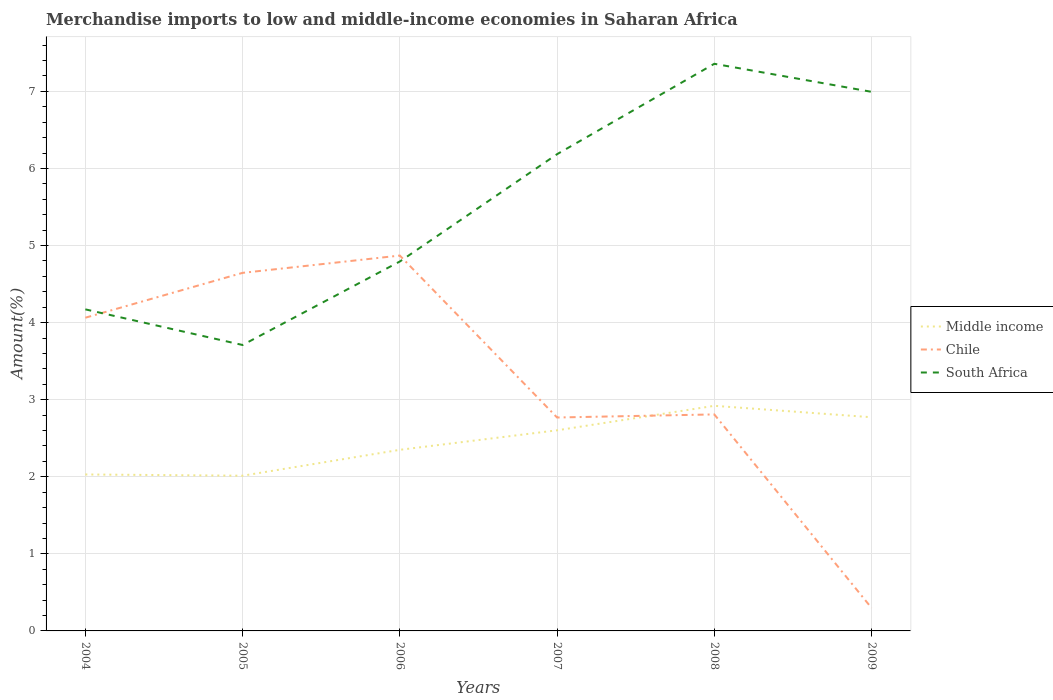Does the line corresponding to Chile intersect with the line corresponding to South Africa?
Offer a very short reply. Yes. Across all years, what is the maximum percentage of amount earned from merchandise imports in Middle income?
Offer a very short reply. 2.01. In which year was the percentage of amount earned from merchandise imports in Middle income maximum?
Give a very brief answer. 2005. What is the total percentage of amount earned from merchandise imports in South Africa in the graph?
Provide a succinct answer. -1.08. What is the difference between the highest and the second highest percentage of amount earned from merchandise imports in Middle income?
Your answer should be very brief. 0.91. What is the difference between the highest and the lowest percentage of amount earned from merchandise imports in Middle income?
Provide a succinct answer. 3. Is the percentage of amount earned from merchandise imports in Middle income strictly greater than the percentage of amount earned from merchandise imports in South Africa over the years?
Ensure brevity in your answer.  Yes. Does the graph contain any zero values?
Your answer should be very brief. No. How many legend labels are there?
Provide a short and direct response. 3. How are the legend labels stacked?
Offer a very short reply. Vertical. What is the title of the graph?
Make the answer very short. Merchandise imports to low and middle-income economies in Saharan Africa. What is the label or title of the Y-axis?
Provide a short and direct response. Amount(%). What is the Amount(%) in Middle income in 2004?
Keep it short and to the point. 2.03. What is the Amount(%) in Chile in 2004?
Offer a terse response. 4.06. What is the Amount(%) in South Africa in 2004?
Offer a very short reply. 4.17. What is the Amount(%) in Middle income in 2005?
Give a very brief answer. 2.01. What is the Amount(%) of Chile in 2005?
Your answer should be very brief. 4.65. What is the Amount(%) of South Africa in 2005?
Keep it short and to the point. 3.71. What is the Amount(%) of Middle income in 2006?
Keep it short and to the point. 2.35. What is the Amount(%) in Chile in 2006?
Keep it short and to the point. 4.87. What is the Amount(%) in South Africa in 2006?
Keep it short and to the point. 4.79. What is the Amount(%) in Middle income in 2007?
Make the answer very short. 2.6. What is the Amount(%) in Chile in 2007?
Your answer should be very brief. 2.77. What is the Amount(%) in South Africa in 2007?
Give a very brief answer. 6.19. What is the Amount(%) in Middle income in 2008?
Make the answer very short. 2.92. What is the Amount(%) of Chile in 2008?
Your answer should be very brief. 2.81. What is the Amount(%) of South Africa in 2008?
Your answer should be compact. 7.36. What is the Amount(%) of Middle income in 2009?
Provide a succinct answer. 2.77. What is the Amount(%) in Chile in 2009?
Your answer should be very brief. 0.3. What is the Amount(%) in South Africa in 2009?
Give a very brief answer. 6.99. Across all years, what is the maximum Amount(%) of Middle income?
Your response must be concise. 2.92. Across all years, what is the maximum Amount(%) of Chile?
Your response must be concise. 4.87. Across all years, what is the maximum Amount(%) of South Africa?
Your response must be concise. 7.36. Across all years, what is the minimum Amount(%) of Middle income?
Offer a terse response. 2.01. Across all years, what is the minimum Amount(%) of Chile?
Offer a terse response. 0.3. Across all years, what is the minimum Amount(%) of South Africa?
Offer a very short reply. 3.71. What is the total Amount(%) in Middle income in the graph?
Offer a terse response. 14.69. What is the total Amount(%) of Chile in the graph?
Ensure brevity in your answer.  19.46. What is the total Amount(%) in South Africa in the graph?
Your response must be concise. 33.21. What is the difference between the Amount(%) of Middle income in 2004 and that in 2005?
Offer a terse response. 0.02. What is the difference between the Amount(%) in Chile in 2004 and that in 2005?
Your answer should be very brief. -0.58. What is the difference between the Amount(%) of South Africa in 2004 and that in 2005?
Ensure brevity in your answer.  0.46. What is the difference between the Amount(%) of Middle income in 2004 and that in 2006?
Provide a short and direct response. -0.32. What is the difference between the Amount(%) of Chile in 2004 and that in 2006?
Make the answer very short. -0.81. What is the difference between the Amount(%) in South Africa in 2004 and that in 2006?
Offer a very short reply. -0.62. What is the difference between the Amount(%) in Middle income in 2004 and that in 2007?
Your answer should be compact. -0.57. What is the difference between the Amount(%) of Chile in 2004 and that in 2007?
Make the answer very short. 1.29. What is the difference between the Amount(%) of South Africa in 2004 and that in 2007?
Keep it short and to the point. -2.01. What is the difference between the Amount(%) of Middle income in 2004 and that in 2008?
Make the answer very short. -0.89. What is the difference between the Amount(%) in Chile in 2004 and that in 2008?
Give a very brief answer. 1.25. What is the difference between the Amount(%) of South Africa in 2004 and that in 2008?
Your answer should be very brief. -3.19. What is the difference between the Amount(%) in Middle income in 2004 and that in 2009?
Your answer should be very brief. -0.74. What is the difference between the Amount(%) in Chile in 2004 and that in 2009?
Provide a succinct answer. 3.77. What is the difference between the Amount(%) of South Africa in 2004 and that in 2009?
Offer a terse response. -2.82. What is the difference between the Amount(%) in Middle income in 2005 and that in 2006?
Ensure brevity in your answer.  -0.34. What is the difference between the Amount(%) in Chile in 2005 and that in 2006?
Make the answer very short. -0.22. What is the difference between the Amount(%) of South Africa in 2005 and that in 2006?
Provide a succinct answer. -1.08. What is the difference between the Amount(%) in Middle income in 2005 and that in 2007?
Provide a succinct answer. -0.59. What is the difference between the Amount(%) of Chile in 2005 and that in 2007?
Make the answer very short. 1.88. What is the difference between the Amount(%) in South Africa in 2005 and that in 2007?
Your answer should be very brief. -2.48. What is the difference between the Amount(%) in Middle income in 2005 and that in 2008?
Provide a short and direct response. -0.91. What is the difference between the Amount(%) in Chile in 2005 and that in 2008?
Ensure brevity in your answer.  1.84. What is the difference between the Amount(%) in South Africa in 2005 and that in 2008?
Keep it short and to the point. -3.65. What is the difference between the Amount(%) in Middle income in 2005 and that in 2009?
Provide a short and direct response. -0.76. What is the difference between the Amount(%) of Chile in 2005 and that in 2009?
Offer a very short reply. 4.35. What is the difference between the Amount(%) in South Africa in 2005 and that in 2009?
Ensure brevity in your answer.  -3.28. What is the difference between the Amount(%) of Middle income in 2006 and that in 2007?
Provide a succinct answer. -0.25. What is the difference between the Amount(%) in Chile in 2006 and that in 2007?
Offer a very short reply. 2.1. What is the difference between the Amount(%) of South Africa in 2006 and that in 2007?
Offer a very short reply. -1.39. What is the difference between the Amount(%) in Middle income in 2006 and that in 2008?
Offer a terse response. -0.57. What is the difference between the Amount(%) in Chile in 2006 and that in 2008?
Your response must be concise. 2.06. What is the difference between the Amount(%) in South Africa in 2006 and that in 2008?
Give a very brief answer. -2.57. What is the difference between the Amount(%) of Middle income in 2006 and that in 2009?
Keep it short and to the point. -0.42. What is the difference between the Amount(%) in Chile in 2006 and that in 2009?
Your answer should be compact. 4.57. What is the difference between the Amount(%) in South Africa in 2006 and that in 2009?
Offer a very short reply. -2.2. What is the difference between the Amount(%) in Middle income in 2007 and that in 2008?
Your answer should be very brief. -0.32. What is the difference between the Amount(%) of Chile in 2007 and that in 2008?
Make the answer very short. -0.04. What is the difference between the Amount(%) of South Africa in 2007 and that in 2008?
Your answer should be very brief. -1.17. What is the difference between the Amount(%) in Middle income in 2007 and that in 2009?
Your response must be concise. -0.17. What is the difference between the Amount(%) of Chile in 2007 and that in 2009?
Ensure brevity in your answer.  2.47. What is the difference between the Amount(%) of South Africa in 2007 and that in 2009?
Offer a very short reply. -0.81. What is the difference between the Amount(%) in Middle income in 2008 and that in 2009?
Your response must be concise. 0.15. What is the difference between the Amount(%) in Chile in 2008 and that in 2009?
Provide a short and direct response. 2.51. What is the difference between the Amount(%) in South Africa in 2008 and that in 2009?
Make the answer very short. 0.36. What is the difference between the Amount(%) of Middle income in 2004 and the Amount(%) of Chile in 2005?
Your answer should be compact. -2.62. What is the difference between the Amount(%) in Middle income in 2004 and the Amount(%) in South Africa in 2005?
Offer a terse response. -1.68. What is the difference between the Amount(%) of Chile in 2004 and the Amount(%) of South Africa in 2005?
Ensure brevity in your answer.  0.35. What is the difference between the Amount(%) of Middle income in 2004 and the Amount(%) of Chile in 2006?
Your answer should be very brief. -2.84. What is the difference between the Amount(%) of Middle income in 2004 and the Amount(%) of South Africa in 2006?
Your answer should be compact. -2.76. What is the difference between the Amount(%) of Chile in 2004 and the Amount(%) of South Africa in 2006?
Your answer should be very brief. -0.73. What is the difference between the Amount(%) of Middle income in 2004 and the Amount(%) of Chile in 2007?
Offer a terse response. -0.74. What is the difference between the Amount(%) in Middle income in 2004 and the Amount(%) in South Africa in 2007?
Provide a succinct answer. -4.16. What is the difference between the Amount(%) of Chile in 2004 and the Amount(%) of South Africa in 2007?
Make the answer very short. -2.12. What is the difference between the Amount(%) in Middle income in 2004 and the Amount(%) in Chile in 2008?
Make the answer very short. -0.78. What is the difference between the Amount(%) of Middle income in 2004 and the Amount(%) of South Africa in 2008?
Provide a succinct answer. -5.33. What is the difference between the Amount(%) of Chile in 2004 and the Amount(%) of South Africa in 2008?
Make the answer very short. -3.29. What is the difference between the Amount(%) in Middle income in 2004 and the Amount(%) in Chile in 2009?
Your answer should be compact. 1.73. What is the difference between the Amount(%) in Middle income in 2004 and the Amount(%) in South Africa in 2009?
Provide a succinct answer. -4.96. What is the difference between the Amount(%) of Chile in 2004 and the Amount(%) of South Africa in 2009?
Your response must be concise. -2.93. What is the difference between the Amount(%) in Middle income in 2005 and the Amount(%) in Chile in 2006?
Your answer should be very brief. -2.86. What is the difference between the Amount(%) in Middle income in 2005 and the Amount(%) in South Africa in 2006?
Your answer should be very brief. -2.78. What is the difference between the Amount(%) in Chile in 2005 and the Amount(%) in South Africa in 2006?
Give a very brief answer. -0.15. What is the difference between the Amount(%) of Middle income in 2005 and the Amount(%) of Chile in 2007?
Provide a short and direct response. -0.76. What is the difference between the Amount(%) of Middle income in 2005 and the Amount(%) of South Africa in 2007?
Give a very brief answer. -4.17. What is the difference between the Amount(%) in Chile in 2005 and the Amount(%) in South Africa in 2007?
Offer a terse response. -1.54. What is the difference between the Amount(%) of Middle income in 2005 and the Amount(%) of Chile in 2008?
Your answer should be compact. -0.8. What is the difference between the Amount(%) in Middle income in 2005 and the Amount(%) in South Africa in 2008?
Your response must be concise. -5.34. What is the difference between the Amount(%) of Chile in 2005 and the Amount(%) of South Africa in 2008?
Your response must be concise. -2.71. What is the difference between the Amount(%) in Middle income in 2005 and the Amount(%) in Chile in 2009?
Keep it short and to the point. 1.72. What is the difference between the Amount(%) of Middle income in 2005 and the Amount(%) of South Africa in 2009?
Provide a short and direct response. -4.98. What is the difference between the Amount(%) of Chile in 2005 and the Amount(%) of South Africa in 2009?
Your answer should be compact. -2.35. What is the difference between the Amount(%) in Middle income in 2006 and the Amount(%) in Chile in 2007?
Your answer should be very brief. -0.42. What is the difference between the Amount(%) in Middle income in 2006 and the Amount(%) in South Africa in 2007?
Your response must be concise. -3.84. What is the difference between the Amount(%) in Chile in 2006 and the Amount(%) in South Africa in 2007?
Provide a short and direct response. -1.32. What is the difference between the Amount(%) in Middle income in 2006 and the Amount(%) in Chile in 2008?
Your response must be concise. -0.46. What is the difference between the Amount(%) in Middle income in 2006 and the Amount(%) in South Africa in 2008?
Ensure brevity in your answer.  -5.01. What is the difference between the Amount(%) in Chile in 2006 and the Amount(%) in South Africa in 2008?
Keep it short and to the point. -2.49. What is the difference between the Amount(%) in Middle income in 2006 and the Amount(%) in Chile in 2009?
Offer a very short reply. 2.05. What is the difference between the Amount(%) of Middle income in 2006 and the Amount(%) of South Africa in 2009?
Give a very brief answer. -4.64. What is the difference between the Amount(%) of Chile in 2006 and the Amount(%) of South Africa in 2009?
Your answer should be compact. -2.12. What is the difference between the Amount(%) in Middle income in 2007 and the Amount(%) in Chile in 2008?
Provide a short and direct response. -0.21. What is the difference between the Amount(%) of Middle income in 2007 and the Amount(%) of South Africa in 2008?
Give a very brief answer. -4.76. What is the difference between the Amount(%) of Chile in 2007 and the Amount(%) of South Africa in 2008?
Offer a terse response. -4.59. What is the difference between the Amount(%) in Middle income in 2007 and the Amount(%) in Chile in 2009?
Offer a very short reply. 2.3. What is the difference between the Amount(%) of Middle income in 2007 and the Amount(%) of South Africa in 2009?
Ensure brevity in your answer.  -4.39. What is the difference between the Amount(%) in Chile in 2007 and the Amount(%) in South Africa in 2009?
Make the answer very short. -4.23. What is the difference between the Amount(%) in Middle income in 2008 and the Amount(%) in Chile in 2009?
Offer a very short reply. 2.62. What is the difference between the Amount(%) of Middle income in 2008 and the Amount(%) of South Africa in 2009?
Provide a succinct answer. -4.07. What is the difference between the Amount(%) of Chile in 2008 and the Amount(%) of South Africa in 2009?
Give a very brief answer. -4.19. What is the average Amount(%) in Middle income per year?
Provide a short and direct response. 2.45. What is the average Amount(%) of Chile per year?
Provide a short and direct response. 3.24. What is the average Amount(%) in South Africa per year?
Make the answer very short. 5.54. In the year 2004, what is the difference between the Amount(%) in Middle income and Amount(%) in Chile?
Ensure brevity in your answer.  -2.03. In the year 2004, what is the difference between the Amount(%) in Middle income and Amount(%) in South Africa?
Provide a short and direct response. -2.14. In the year 2004, what is the difference between the Amount(%) in Chile and Amount(%) in South Africa?
Ensure brevity in your answer.  -0.11. In the year 2005, what is the difference between the Amount(%) in Middle income and Amount(%) in Chile?
Offer a very short reply. -2.63. In the year 2005, what is the difference between the Amount(%) of Middle income and Amount(%) of South Africa?
Keep it short and to the point. -1.7. In the year 2005, what is the difference between the Amount(%) in Chile and Amount(%) in South Africa?
Provide a succinct answer. 0.94. In the year 2006, what is the difference between the Amount(%) of Middle income and Amount(%) of Chile?
Provide a succinct answer. -2.52. In the year 2006, what is the difference between the Amount(%) of Middle income and Amount(%) of South Africa?
Provide a succinct answer. -2.44. In the year 2006, what is the difference between the Amount(%) of Chile and Amount(%) of South Africa?
Give a very brief answer. 0.08. In the year 2007, what is the difference between the Amount(%) of Middle income and Amount(%) of Chile?
Offer a terse response. -0.17. In the year 2007, what is the difference between the Amount(%) of Middle income and Amount(%) of South Africa?
Your response must be concise. -3.58. In the year 2007, what is the difference between the Amount(%) of Chile and Amount(%) of South Africa?
Provide a succinct answer. -3.42. In the year 2008, what is the difference between the Amount(%) of Middle income and Amount(%) of Chile?
Your response must be concise. 0.11. In the year 2008, what is the difference between the Amount(%) in Middle income and Amount(%) in South Africa?
Give a very brief answer. -4.44. In the year 2008, what is the difference between the Amount(%) of Chile and Amount(%) of South Africa?
Your response must be concise. -4.55. In the year 2009, what is the difference between the Amount(%) in Middle income and Amount(%) in Chile?
Keep it short and to the point. 2.47. In the year 2009, what is the difference between the Amount(%) of Middle income and Amount(%) of South Africa?
Your response must be concise. -4.22. In the year 2009, what is the difference between the Amount(%) in Chile and Amount(%) in South Africa?
Make the answer very short. -6.7. What is the ratio of the Amount(%) of Middle income in 2004 to that in 2005?
Your response must be concise. 1.01. What is the ratio of the Amount(%) in Chile in 2004 to that in 2005?
Make the answer very short. 0.87. What is the ratio of the Amount(%) in South Africa in 2004 to that in 2005?
Ensure brevity in your answer.  1.12. What is the ratio of the Amount(%) in Middle income in 2004 to that in 2006?
Offer a terse response. 0.86. What is the ratio of the Amount(%) in Chile in 2004 to that in 2006?
Your answer should be compact. 0.83. What is the ratio of the Amount(%) in South Africa in 2004 to that in 2006?
Your answer should be compact. 0.87. What is the ratio of the Amount(%) in Middle income in 2004 to that in 2007?
Your answer should be compact. 0.78. What is the ratio of the Amount(%) in Chile in 2004 to that in 2007?
Your answer should be compact. 1.47. What is the ratio of the Amount(%) in South Africa in 2004 to that in 2007?
Keep it short and to the point. 0.67. What is the ratio of the Amount(%) in Middle income in 2004 to that in 2008?
Make the answer very short. 0.69. What is the ratio of the Amount(%) in Chile in 2004 to that in 2008?
Your response must be concise. 1.45. What is the ratio of the Amount(%) of South Africa in 2004 to that in 2008?
Ensure brevity in your answer.  0.57. What is the ratio of the Amount(%) of Middle income in 2004 to that in 2009?
Your answer should be very brief. 0.73. What is the ratio of the Amount(%) of Chile in 2004 to that in 2009?
Make the answer very short. 13.63. What is the ratio of the Amount(%) of South Africa in 2004 to that in 2009?
Keep it short and to the point. 0.6. What is the ratio of the Amount(%) in Middle income in 2005 to that in 2006?
Provide a short and direct response. 0.86. What is the ratio of the Amount(%) in Chile in 2005 to that in 2006?
Provide a succinct answer. 0.95. What is the ratio of the Amount(%) of South Africa in 2005 to that in 2006?
Your response must be concise. 0.77. What is the ratio of the Amount(%) in Middle income in 2005 to that in 2007?
Keep it short and to the point. 0.77. What is the ratio of the Amount(%) in Chile in 2005 to that in 2007?
Your answer should be compact. 1.68. What is the ratio of the Amount(%) in South Africa in 2005 to that in 2007?
Make the answer very short. 0.6. What is the ratio of the Amount(%) in Middle income in 2005 to that in 2008?
Your answer should be very brief. 0.69. What is the ratio of the Amount(%) of Chile in 2005 to that in 2008?
Provide a short and direct response. 1.65. What is the ratio of the Amount(%) in South Africa in 2005 to that in 2008?
Offer a terse response. 0.5. What is the ratio of the Amount(%) in Middle income in 2005 to that in 2009?
Offer a very short reply. 0.73. What is the ratio of the Amount(%) of Chile in 2005 to that in 2009?
Provide a short and direct response. 15.58. What is the ratio of the Amount(%) of South Africa in 2005 to that in 2009?
Your answer should be compact. 0.53. What is the ratio of the Amount(%) of Middle income in 2006 to that in 2007?
Your answer should be compact. 0.9. What is the ratio of the Amount(%) of Chile in 2006 to that in 2007?
Your answer should be compact. 1.76. What is the ratio of the Amount(%) of South Africa in 2006 to that in 2007?
Give a very brief answer. 0.77. What is the ratio of the Amount(%) of Middle income in 2006 to that in 2008?
Offer a terse response. 0.8. What is the ratio of the Amount(%) in Chile in 2006 to that in 2008?
Your response must be concise. 1.73. What is the ratio of the Amount(%) of South Africa in 2006 to that in 2008?
Provide a succinct answer. 0.65. What is the ratio of the Amount(%) in Middle income in 2006 to that in 2009?
Provide a short and direct response. 0.85. What is the ratio of the Amount(%) of Chile in 2006 to that in 2009?
Ensure brevity in your answer.  16.33. What is the ratio of the Amount(%) in South Africa in 2006 to that in 2009?
Your response must be concise. 0.69. What is the ratio of the Amount(%) in Middle income in 2007 to that in 2008?
Your answer should be very brief. 0.89. What is the ratio of the Amount(%) of Chile in 2007 to that in 2008?
Offer a very short reply. 0.99. What is the ratio of the Amount(%) in South Africa in 2007 to that in 2008?
Keep it short and to the point. 0.84. What is the ratio of the Amount(%) in Middle income in 2007 to that in 2009?
Ensure brevity in your answer.  0.94. What is the ratio of the Amount(%) in Chile in 2007 to that in 2009?
Ensure brevity in your answer.  9.29. What is the ratio of the Amount(%) of South Africa in 2007 to that in 2009?
Offer a very short reply. 0.88. What is the ratio of the Amount(%) of Middle income in 2008 to that in 2009?
Your answer should be very brief. 1.05. What is the ratio of the Amount(%) of Chile in 2008 to that in 2009?
Your response must be concise. 9.42. What is the ratio of the Amount(%) of South Africa in 2008 to that in 2009?
Provide a short and direct response. 1.05. What is the difference between the highest and the second highest Amount(%) of Middle income?
Provide a short and direct response. 0.15. What is the difference between the highest and the second highest Amount(%) of Chile?
Ensure brevity in your answer.  0.22. What is the difference between the highest and the second highest Amount(%) of South Africa?
Offer a terse response. 0.36. What is the difference between the highest and the lowest Amount(%) of Middle income?
Keep it short and to the point. 0.91. What is the difference between the highest and the lowest Amount(%) in Chile?
Your answer should be very brief. 4.57. What is the difference between the highest and the lowest Amount(%) in South Africa?
Give a very brief answer. 3.65. 